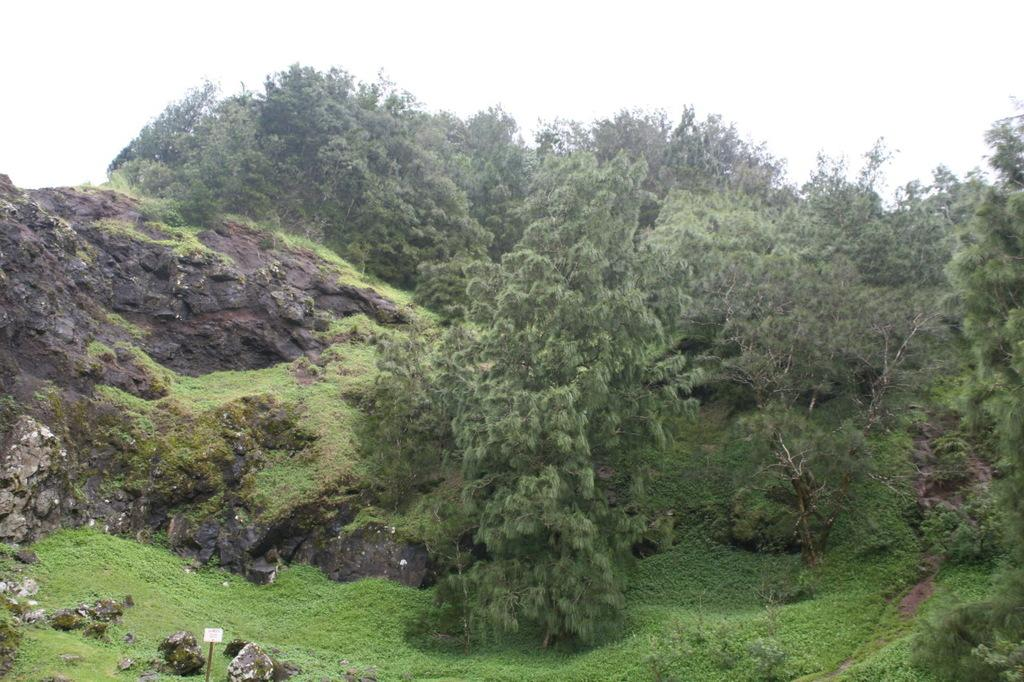What type of vegetation is present in the image? There are many trees and plants in the image. What is the color of the grass at the bottom of the image? The grass at the bottom of the image is green. What geographical feature can be seen to the left of the image? There are mountains to the left of the image. What part of the natural environment is visible at the top of the image? The sky is visible at the top of the image. Where is the market located in the image? There is no market present in the image. Is it raining in the image? There is no indication of rain in the image. 